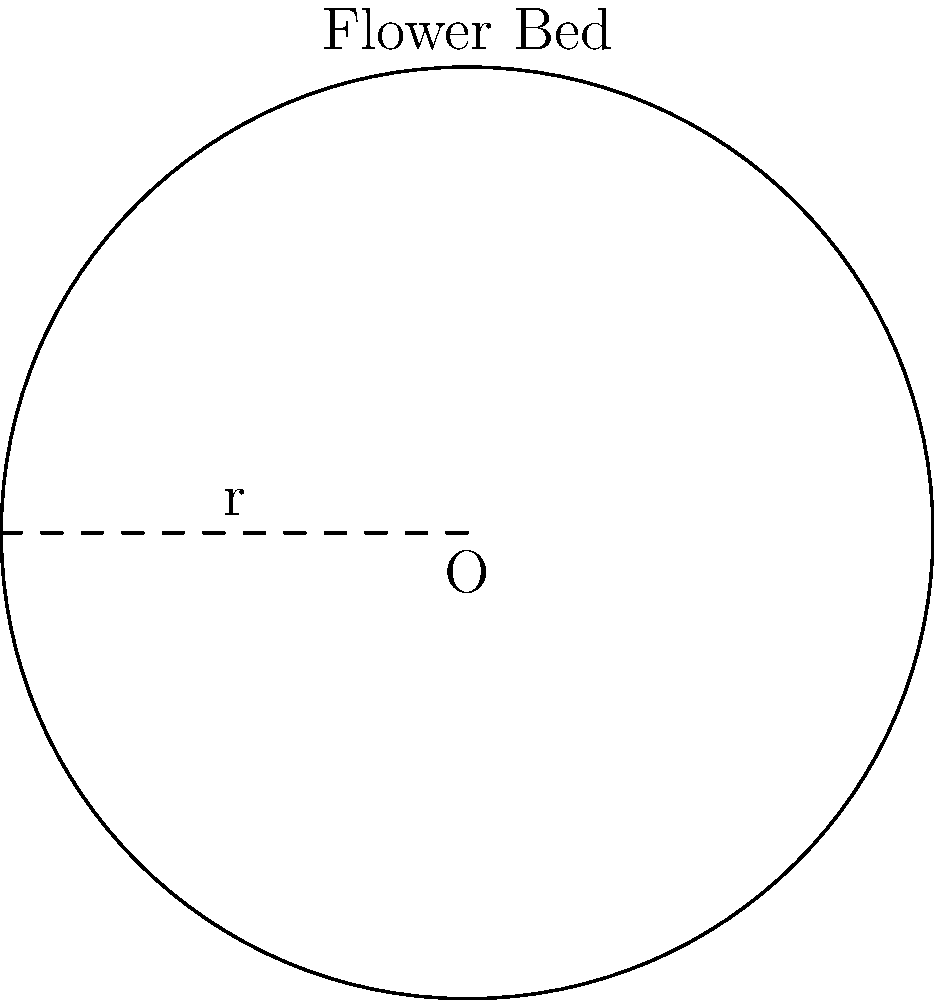You've decided to create a circular flower bed in your beautiful backyard. If the radius of the flower bed is 3 meters, what is the area of the flower bed? Use $\pi \approx 3.14$ for your calculations. To find the area of a circular flower bed, we need to use the formula for the area of a circle:

$$A = \pi r^2$$

Where:
$A$ is the area of the circle
$\pi$ is approximately 3.14
$r$ is the radius of the circle

Given:
- The radius of the flower bed is 3 meters
- $\pi \approx 3.14$

Let's substitute these values into the formula:

$$\begin{align*}
A &= \pi r^2 \\
A &= 3.14 \times 3^2 \\
A &= 3.14 \times 9 \\
A &= 28.26
\end{align*}$$

Therefore, the area of the circular flower bed is approximately 28.26 square meters.
Answer: 28.26 m² 